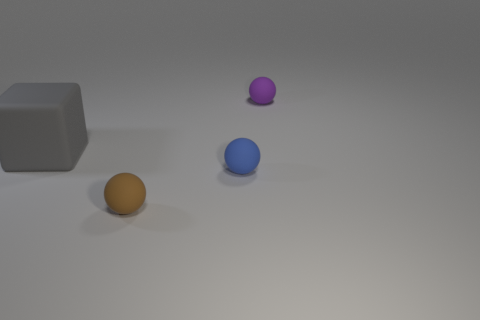Are the small ball behind the large gray thing and the small brown thing made of the same material?
Make the answer very short. Yes. There is a thing that is both behind the small blue sphere and to the left of the small purple matte sphere; what material is it?
Provide a succinct answer. Rubber. What material is the thing to the left of the rubber sphere to the left of the small blue sphere?
Your response must be concise. Rubber. How big is the matte sphere that is behind the thing that is on the left side of the matte ball that is in front of the blue matte object?
Provide a succinct answer. Small. What number of small blue objects have the same material as the tiny brown sphere?
Make the answer very short. 1. There is a matte object that is left of the tiny brown rubber ball that is in front of the gray matte object; what color is it?
Your response must be concise. Gray. What number of objects are big rubber cubes or small objects left of the purple matte sphere?
Your answer should be compact. 3. Are there any things that have the same color as the block?
Your response must be concise. No. How many yellow objects are large rubber objects or small shiny spheres?
Offer a very short reply. 0. How many other things are there of the same size as the gray block?
Offer a terse response. 0. 